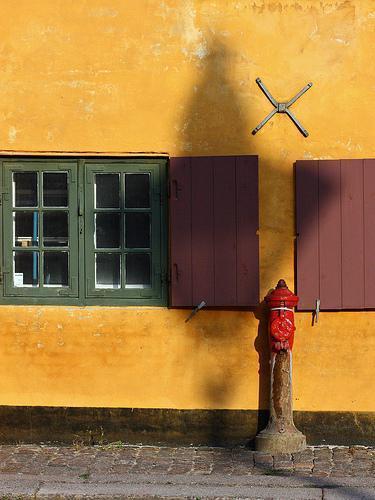How many windows are visible?
Give a very brief answer. 2. 